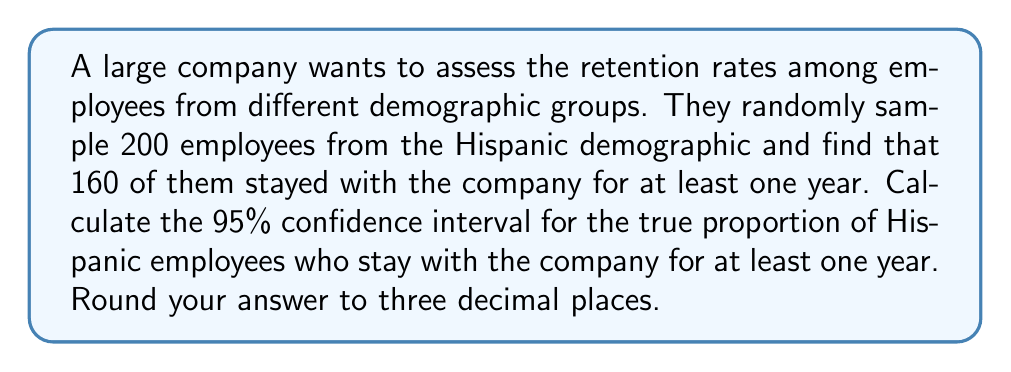Can you solve this math problem? Let's approach this step-by-step:

1) First, we need to calculate the sample proportion:
   $\hat{p} = \frac{\text{number of successes}}{\text{sample size}} = \frac{160}{200} = 0.8$

2) The formula for the confidence interval is:
   $$\hat{p} \pm z_{\alpha/2} \sqrt{\frac{\hat{p}(1-\hat{p})}{n}}$$
   
   Where:
   - $\hat{p}$ is the sample proportion
   - $z_{\alpha/2}$ is the critical value (for 95% confidence, this is 1.96)
   - $n$ is the sample size

3) Let's substitute our values:
   $$0.8 \pm 1.96 \sqrt{\frac{0.8(1-0.8)}{200}}$$

4) Simplify inside the square root:
   $$0.8 \pm 1.96 \sqrt{\frac{0.8(0.2)}{200}} = 0.8 \pm 1.96 \sqrt{\frac{0.16}{200}}$$

5) Calculate:
   $$0.8 \pm 1.96 \sqrt{0.0008} = 0.8 \pm 1.96(0.0283)$$
   $$0.8 \pm 0.0555$$

6) Therefore, the confidence interval is:
   $$(0.8 - 0.0555, 0.8 + 0.0555) = (0.7445, 0.8555)$$

7) Rounding to three decimal places:
   $$(0.745, 0.856)$$
Answer: (0.745, 0.856) 